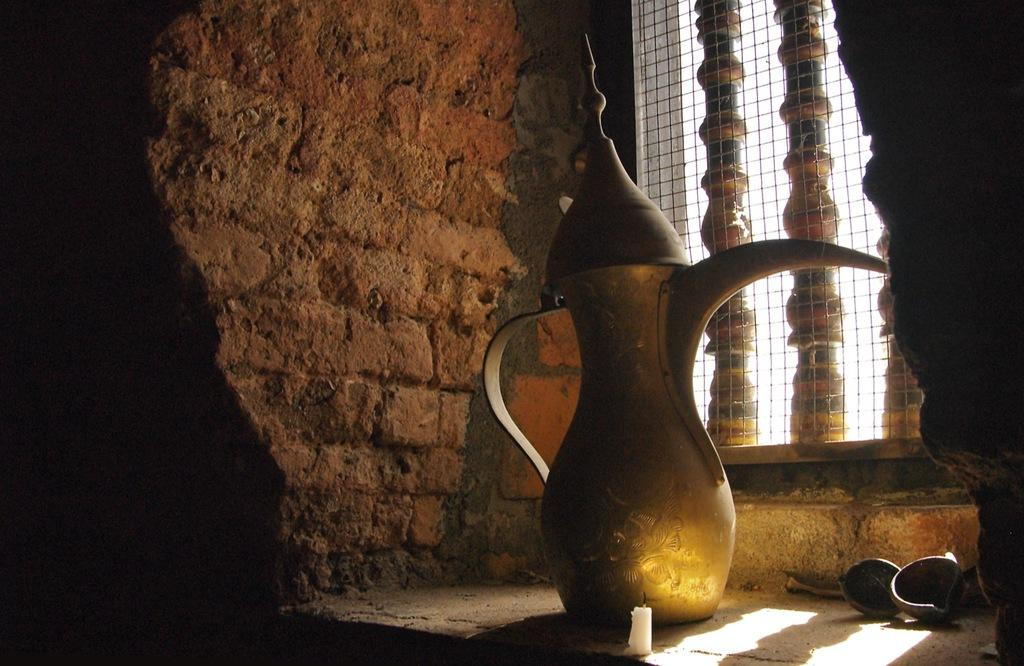What type of jug is visible in the image? There is a copper jug in the image. What other objects can be seen in the image? There are diyas and a candle in the image. What is visible in the background of the image? There is a wall and an iron net in the background of the image. How many books are stacked on the copper jug in the image? There are no books present in the image; it only features a copper jug, diyas, a candle, a wall, and an iron net. 